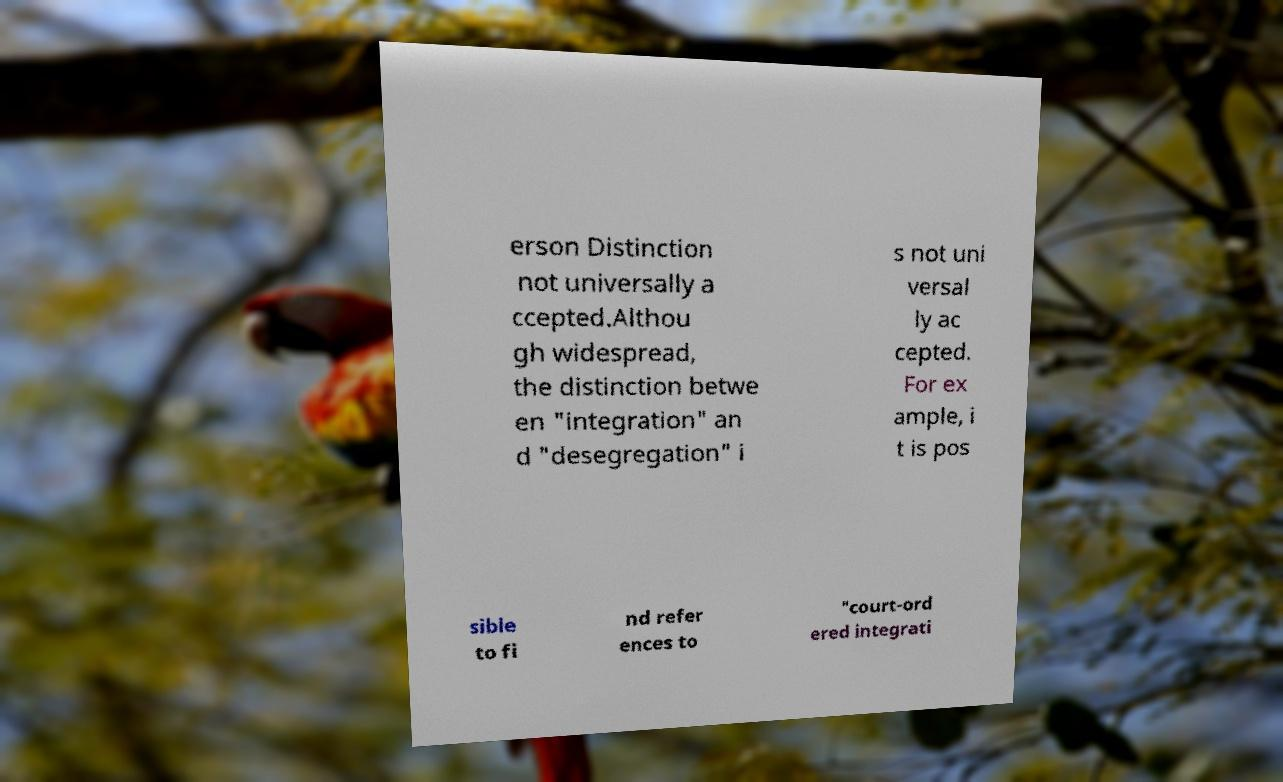Please identify and transcribe the text found in this image. erson Distinction not universally a ccepted.Althou gh widespread, the distinction betwe en "integration" an d "desegregation" i s not uni versal ly ac cepted. For ex ample, i t is pos sible to fi nd refer ences to "court-ord ered integrati 